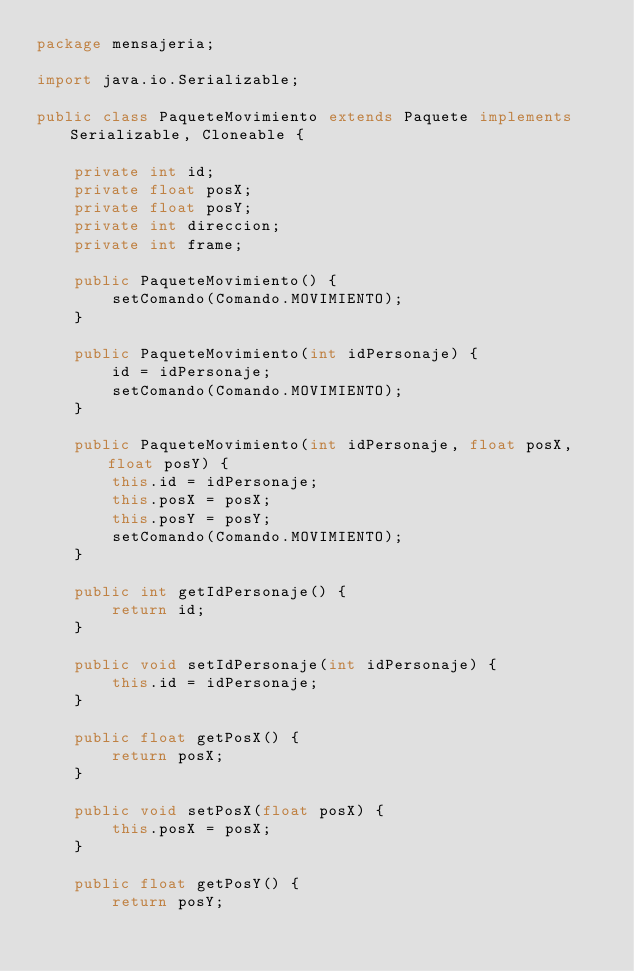Convert code to text. <code><loc_0><loc_0><loc_500><loc_500><_Java_>package mensajeria;

import java.io.Serializable;

public class PaqueteMovimiento extends Paquete implements Serializable, Cloneable {

	private int id;
	private float posX;
	private float posY;
	private int direccion;
	private int frame;

	public PaqueteMovimiento() {
		setComando(Comando.MOVIMIENTO);
	}

	public PaqueteMovimiento(int idPersonaje) {
		id = idPersonaje;
		setComando(Comando.MOVIMIENTO);
	}
	
	public PaqueteMovimiento(int idPersonaje, float posX, float posY) {
		this.id = idPersonaje;
		this.posX = posX;
		this.posY = posY;
		setComando(Comando.MOVIMIENTO);
	}

	public int getIdPersonaje() {
		return id;
	}

	public void setIdPersonaje(int idPersonaje) {
		this.id = idPersonaje;
	}

	public float getPosX() {
		return posX;
	}

	public void setPosX(float posX) {
		this.posX = posX;
	}

	public float getPosY() {
		return posY;</code> 